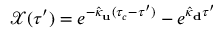Convert formula to latex. <formula><loc_0><loc_0><loc_500><loc_500>\begin{array} { r } { \mathcal { X } ( \tau ^ { \prime } ) = e ^ { - \hat { \kappa } _ { u } ( \tau _ { c } - \tau ^ { \prime } ) } - e ^ { \hat { \kappa } _ { d } \tau ^ { \prime } } } \end{array}</formula> 